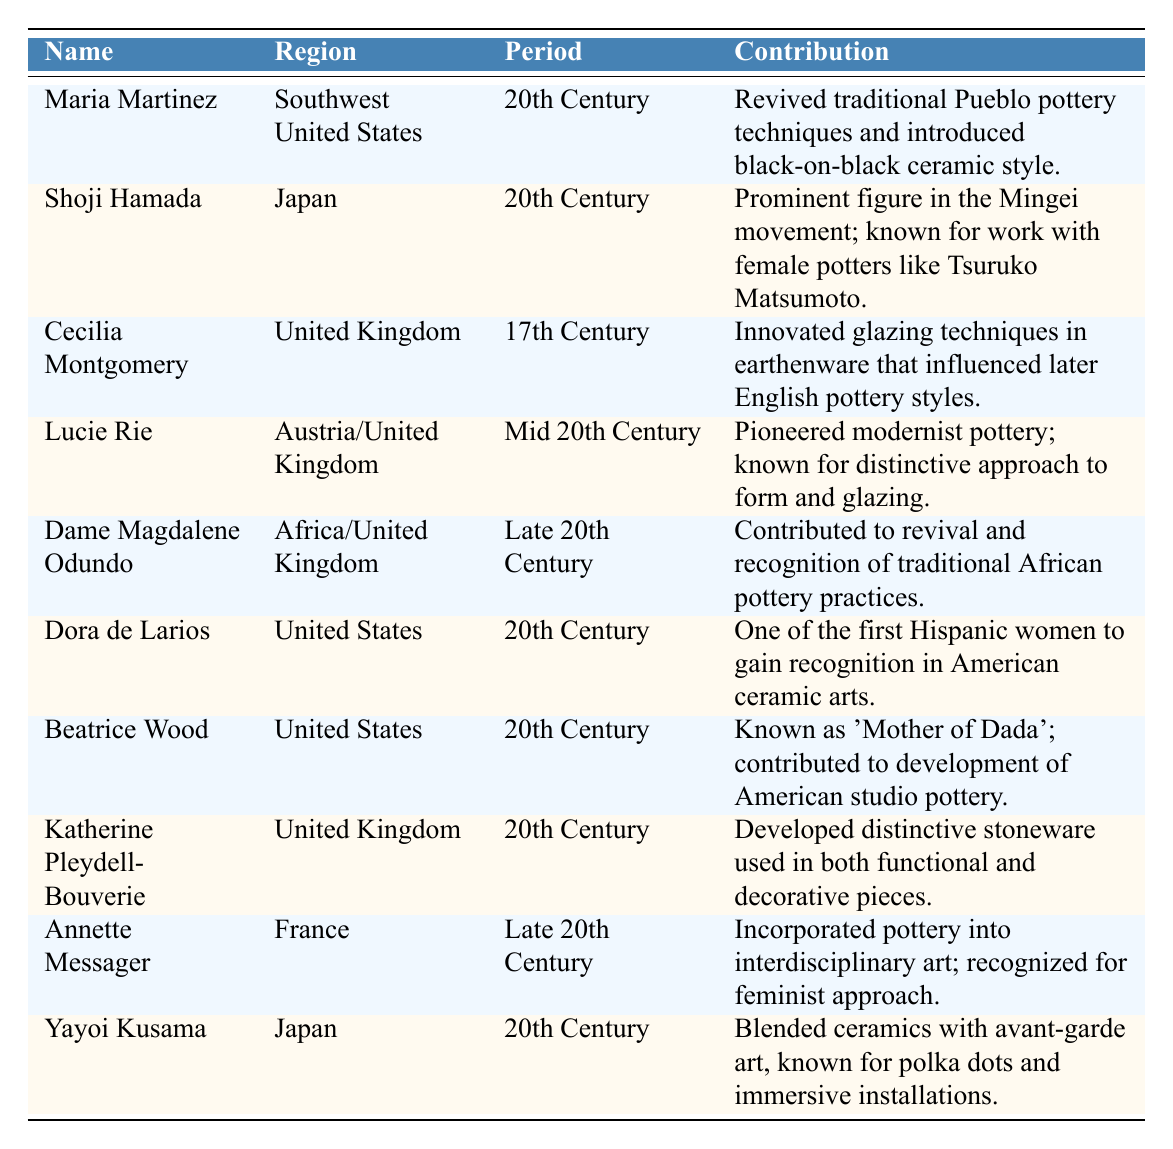What is the contribution of Maria Martinez? The table lists that Maria Martinez is known for reviving traditional Pueblo pottery techniques and introducing the black-on-black ceramic style.
Answer: Revived traditional Pueblo pottery techniques and introduced black-on-black ceramic style Which region does Lucie Rie belong to? According to the table, Lucie Rie is associated with both Austria and the United Kingdom.
Answer: Austria/United Kingdom How many potters are noted from the 20th Century? The table shows a total of 6 potters listed under the 20th Century: Maria Martinez, Shoji Hamada, Dora de Larios, Beatrice Wood, Katherine Pleydell-Bouverie, and Yayoi Kusama.
Answer: 6 Is Cecilia Montgomery associated with the United Kingdom? The table provides that Cecilia Montgomery is indeed from the United Kingdom.
Answer: Yes What two contributions did female potters from Japan make in the 20th Century? The table highlights contributions from Shoji Hamada, known for his connections with female potters, and Yayoi Kusama, recognized for blending ceramics with avant-garde art.
Answer: Connections with female potters and blending ceramics with avant-garde art Count the number of potters associated with Africa or the United Kingdom and provide their names. The table includes one potter connected to both Africa and the United Kingdom, Dame Magdalene Odundo.
Answer: 1, Dame Magdalene Odundo Which potter is known as the 'Mother of Dada'? According to the table, Beatrice Wood is recognized as the 'Mother of Dada.'
Answer: Beatrice Wood What influence did Cecilia Montgomery have on later pottery styles? The table states that Cecilia Montgomery innovated glazing techniques that influenced later English pottery styles.
Answer: Innovated glazing techniques influencing later English pottery styles Identify the contribution of female potters in the late 20th Century. The table outlines two contributions: Dame Magdalene Odundo's revival of traditional African pottery and Annette Messager's incorporation of pottery into interdisciplinary art with a feminist approach.
Answer: Revival of traditional African pottery and interdisciplinary art with a feminist approach Which potters contributed to the development of pottery practices outside the traditional realm? Based on the table, both Annette Messager and Yayoi Kusama are noted for their contributions to interdisciplinary art and avant-garde ceramics, respectively.
Answer: Annette Messager and Yayoi Kusama 